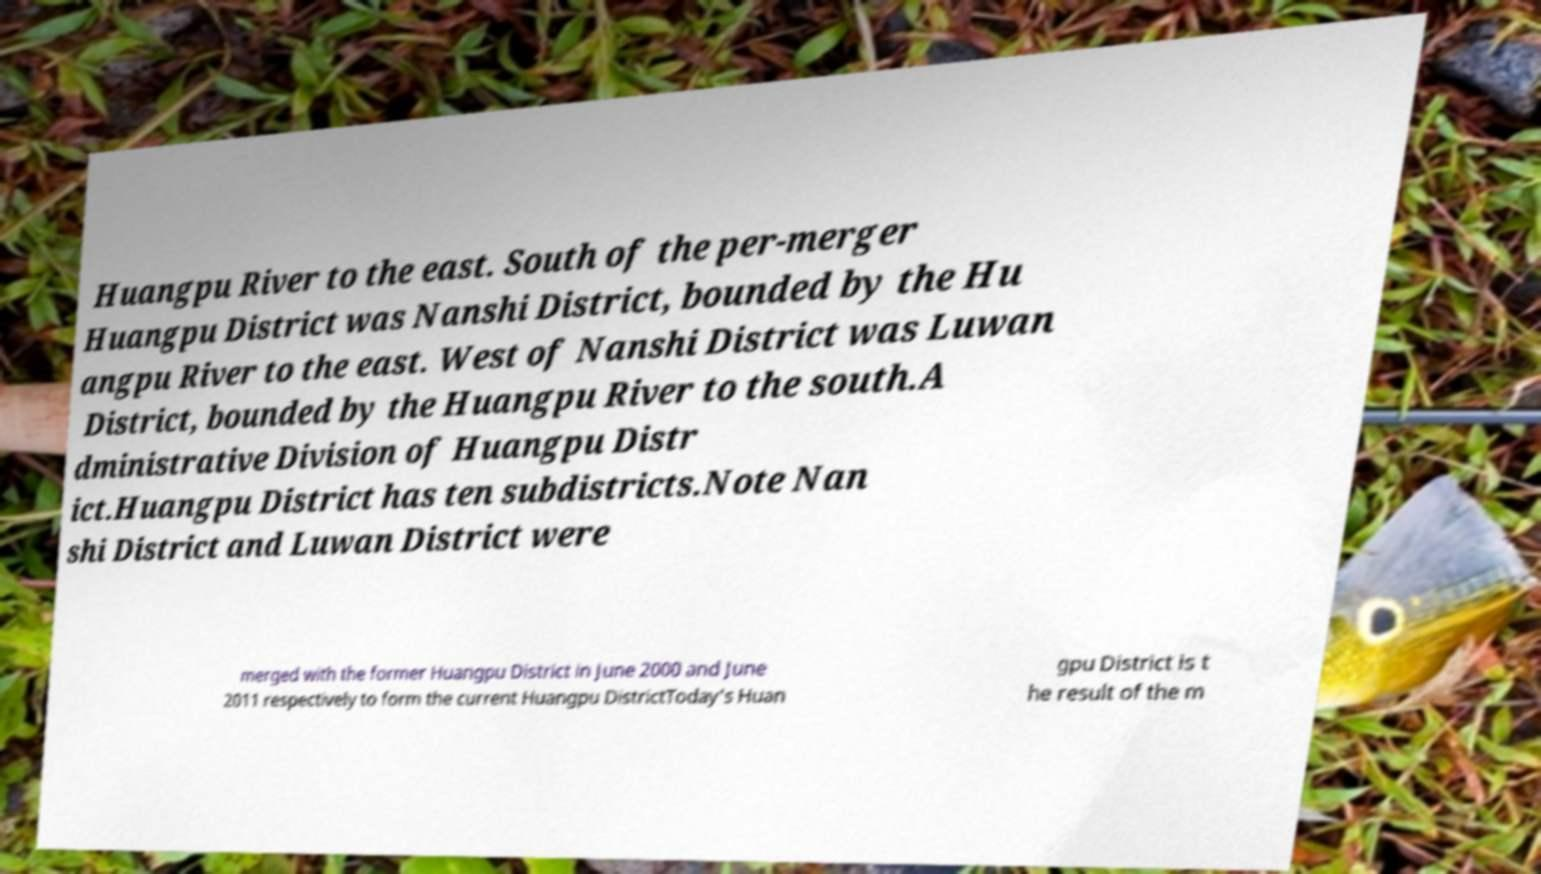Please read and relay the text visible in this image. What does it say? Huangpu River to the east. South of the per-merger Huangpu District was Nanshi District, bounded by the Hu angpu River to the east. West of Nanshi District was Luwan District, bounded by the Huangpu River to the south.A dministrative Division of Huangpu Distr ict.Huangpu District has ten subdistricts.Note Nan shi District and Luwan District were merged with the former Huangpu District in June 2000 and June 2011 respectively to form the current Huangpu DistrictToday's Huan gpu District is t he result of the m 